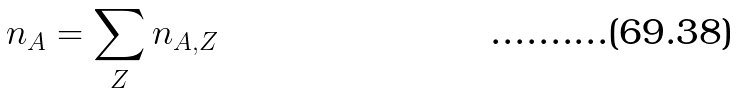<formula> <loc_0><loc_0><loc_500><loc_500>n _ { A } = \sum _ { Z } n _ { A , Z }</formula> 